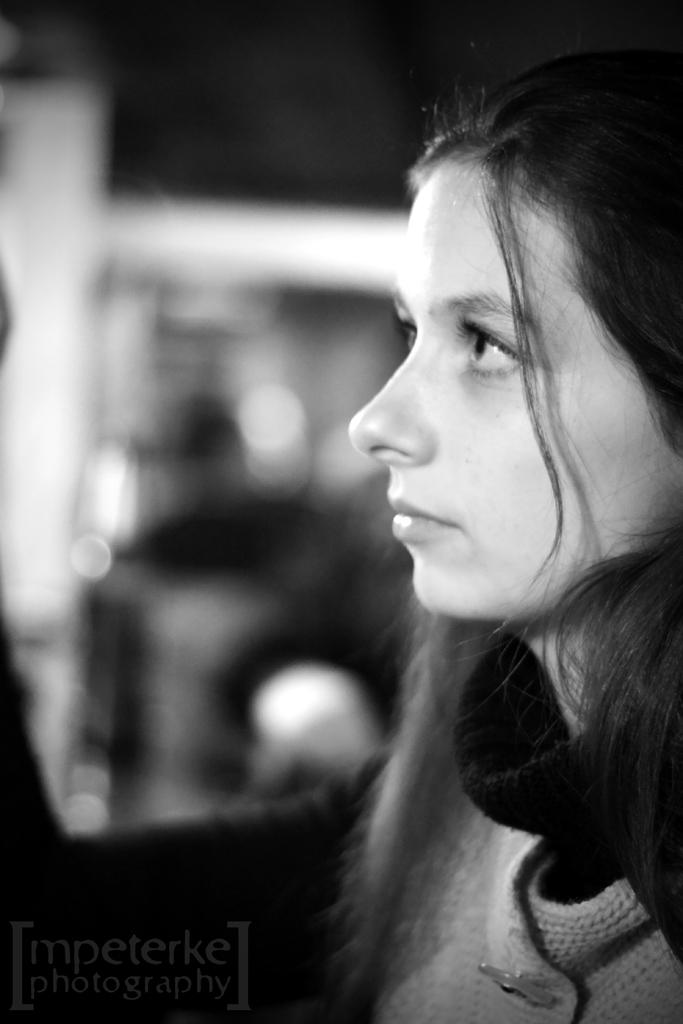What is the color scheme of the image? The image is black and white. Where is the woman located in the image? The woman is on the right side of the image. How would you describe the background of the image? The background of the image is blurry. What can be found at the bottom of the image? There is text at the bottom of the image. What type of produce is being harvested in the image? There is no produce or harvesting activity present in the image; it is a black and white image featuring a woman with a blurry background and text at the bottom. 